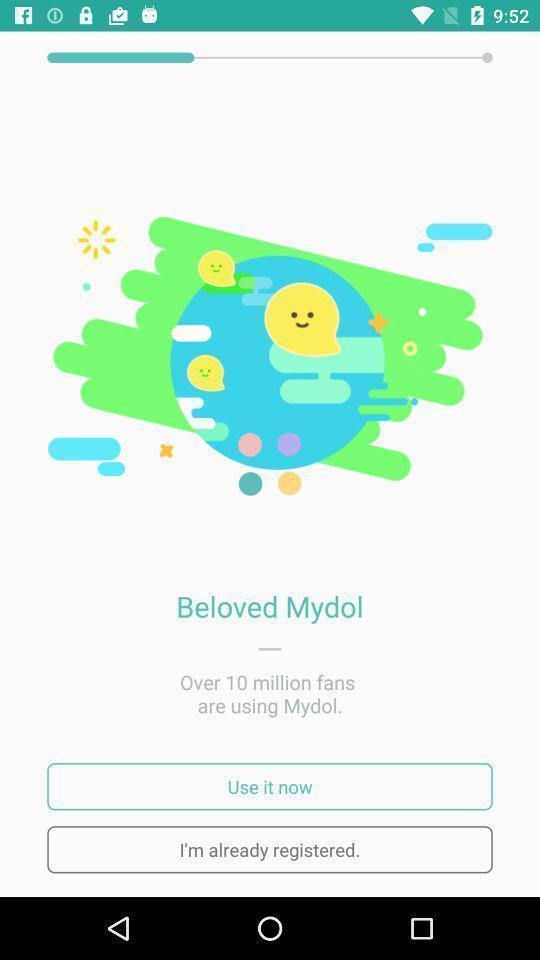Describe the content in this image. Page displaying registration option for the app. 